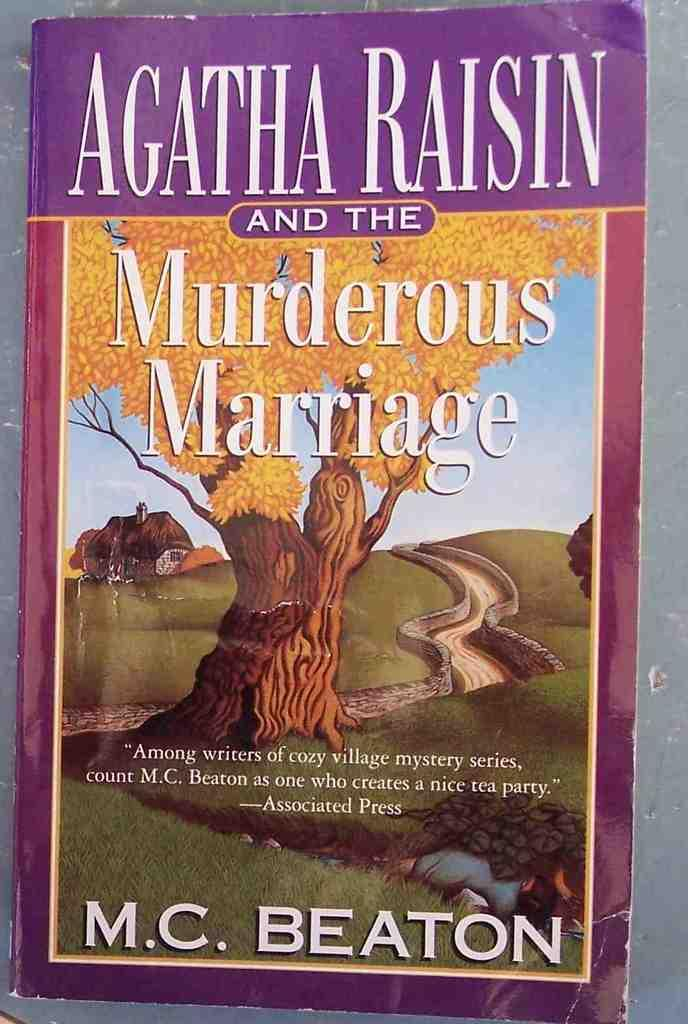<image>
Summarize the visual content of the image. A book called Agatha Raisin and the Murderous Marriage 